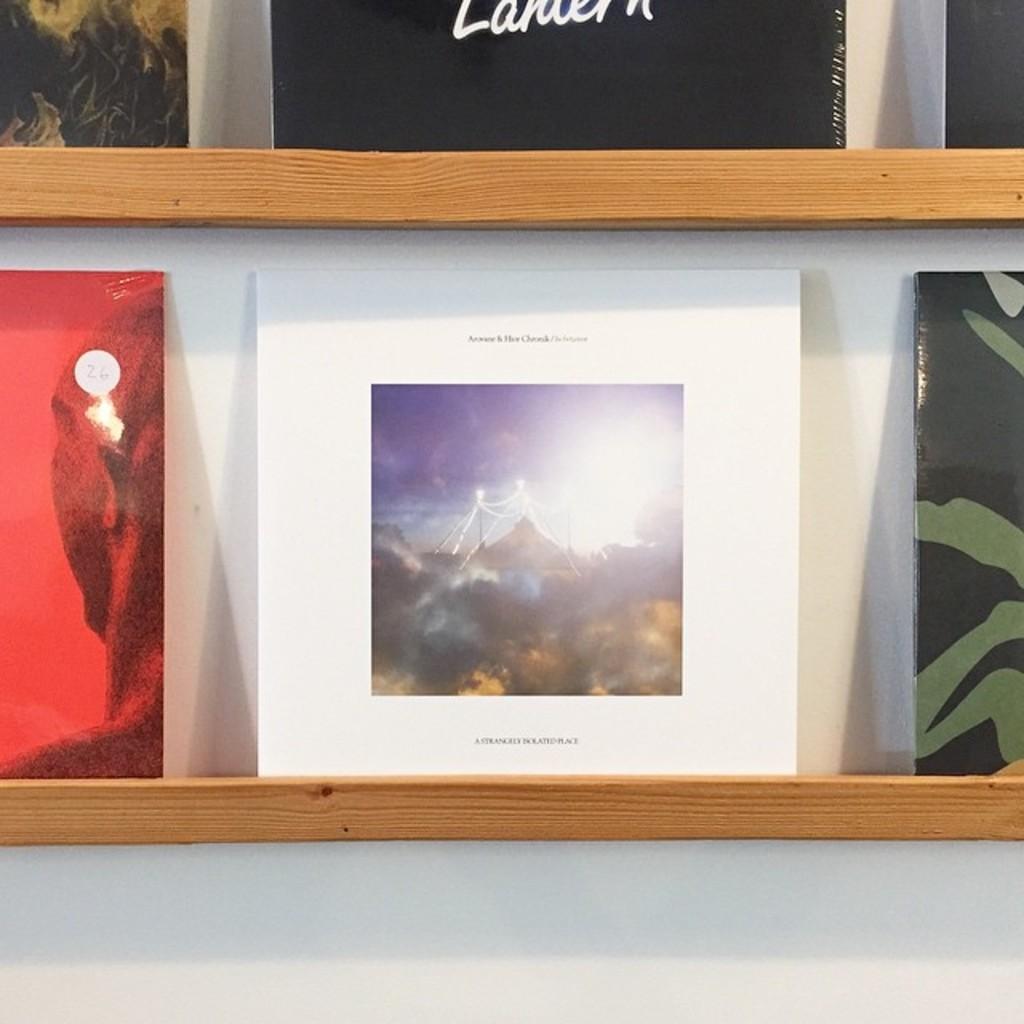What color is the frame of the picture?
Offer a very short reply. Answering does not require reading text in the image. 